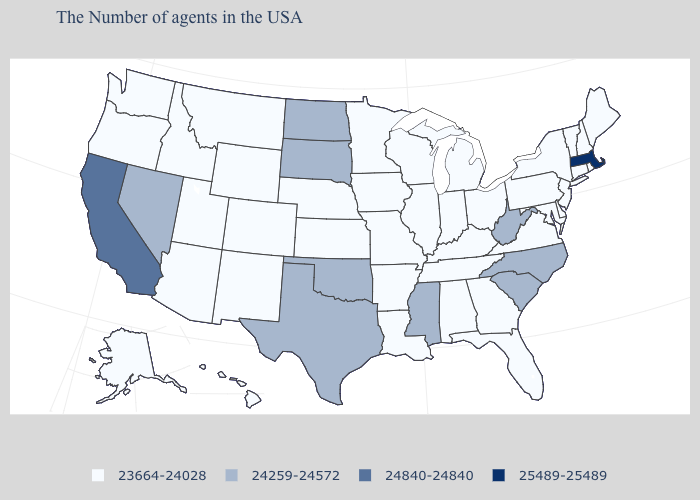Name the states that have a value in the range 23664-24028?
Give a very brief answer. Maine, Rhode Island, New Hampshire, Vermont, Connecticut, New York, New Jersey, Delaware, Maryland, Pennsylvania, Virginia, Ohio, Florida, Georgia, Michigan, Kentucky, Indiana, Alabama, Tennessee, Wisconsin, Illinois, Louisiana, Missouri, Arkansas, Minnesota, Iowa, Kansas, Nebraska, Wyoming, Colorado, New Mexico, Utah, Montana, Arizona, Idaho, Washington, Oregon, Alaska, Hawaii. Does Indiana have the lowest value in the MidWest?
Quick response, please. Yes. Name the states that have a value in the range 24259-24572?
Be succinct. North Carolina, South Carolina, West Virginia, Mississippi, Oklahoma, Texas, South Dakota, North Dakota, Nevada. Name the states that have a value in the range 24259-24572?
Concise answer only. North Carolina, South Carolina, West Virginia, Mississippi, Oklahoma, Texas, South Dakota, North Dakota, Nevada. Does Massachusetts have the highest value in the USA?
Be succinct. Yes. What is the value of Connecticut?
Concise answer only. 23664-24028. Name the states that have a value in the range 25489-25489?
Answer briefly. Massachusetts. How many symbols are there in the legend?
Quick response, please. 4. What is the highest value in the South ?
Be succinct. 24259-24572. What is the highest value in the South ?
Keep it brief. 24259-24572. Name the states that have a value in the range 24259-24572?
Write a very short answer. North Carolina, South Carolina, West Virginia, Mississippi, Oklahoma, Texas, South Dakota, North Dakota, Nevada. What is the highest value in the USA?
Concise answer only. 25489-25489. What is the highest value in the MidWest ?
Give a very brief answer. 24259-24572. How many symbols are there in the legend?
Quick response, please. 4. Is the legend a continuous bar?
Answer briefly. No. 